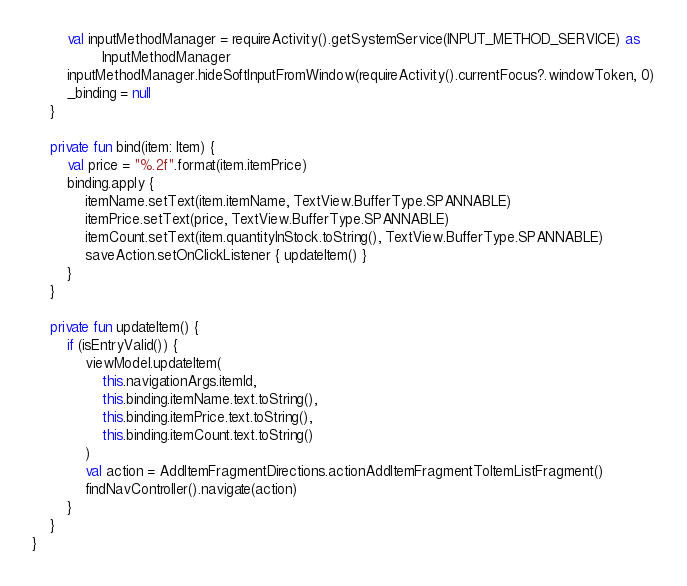<code> <loc_0><loc_0><loc_500><loc_500><_Kotlin_>        val inputMethodManager = requireActivity().getSystemService(INPUT_METHOD_SERVICE) as
                InputMethodManager
        inputMethodManager.hideSoftInputFromWindow(requireActivity().currentFocus?.windowToken, 0)
        _binding = null
    }

    private fun bind(item: Item) {
        val price = "%.2f".format(item.itemPrice)
        binding.apply {
            itemName.setText(item.itemName, TextView.BufferType.SPANNABLE)
            itemPrice.setText(price, TextView.BufferType.SPANNABLE)
            itemCount.setText(item.quantityInStock.toString(), TextView.BufferType.SPANNABLE)
            saveAction.setOnClickListener { updateItem() }
        }
    }

    private fun updateItem() {
        if (isEntryValid()) {
            viewModel.updateItem(
                this.navigationArgs.itemId,
                this.binding.itemName.text.toString(),
                this.binding.itemPrice.text.toString(),
                this.binding.itemCount.text.toString()
            )
            val action = AddItemFragmentDirections.actionAddItemFragmentToItemListFragment()
            findNavController().navigate(action)
        }
    }
}
</code> 